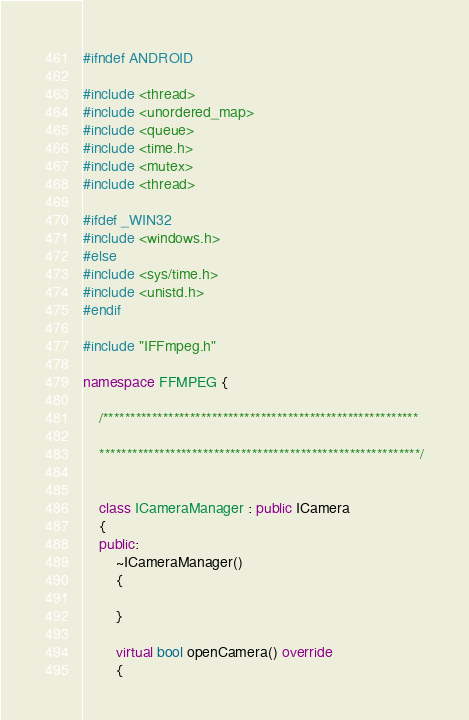Convert code to text. <code><loc_0><loc_0><loc_500><loc_500><_C++_>
#ifndef ANDROID

#include <thread>
#include <unordered_map>
#include <queue>
#include <time.h>
#include <mutex>
#include <thread>

#ifdef _WIN32
#include <windows.h>
#else
#include <sys/time.h>
#include <unistd.h>
#endif

#include "IFFmpeg.h"

namespace FFMPEG {
	
	/**********************************************************

	***********************************************************/


	class ICameraManager : public ICamera
	{
	public:
		~ICameraManager()
		{

		}
		
		virtual bool openCamera() override
		{</code> 